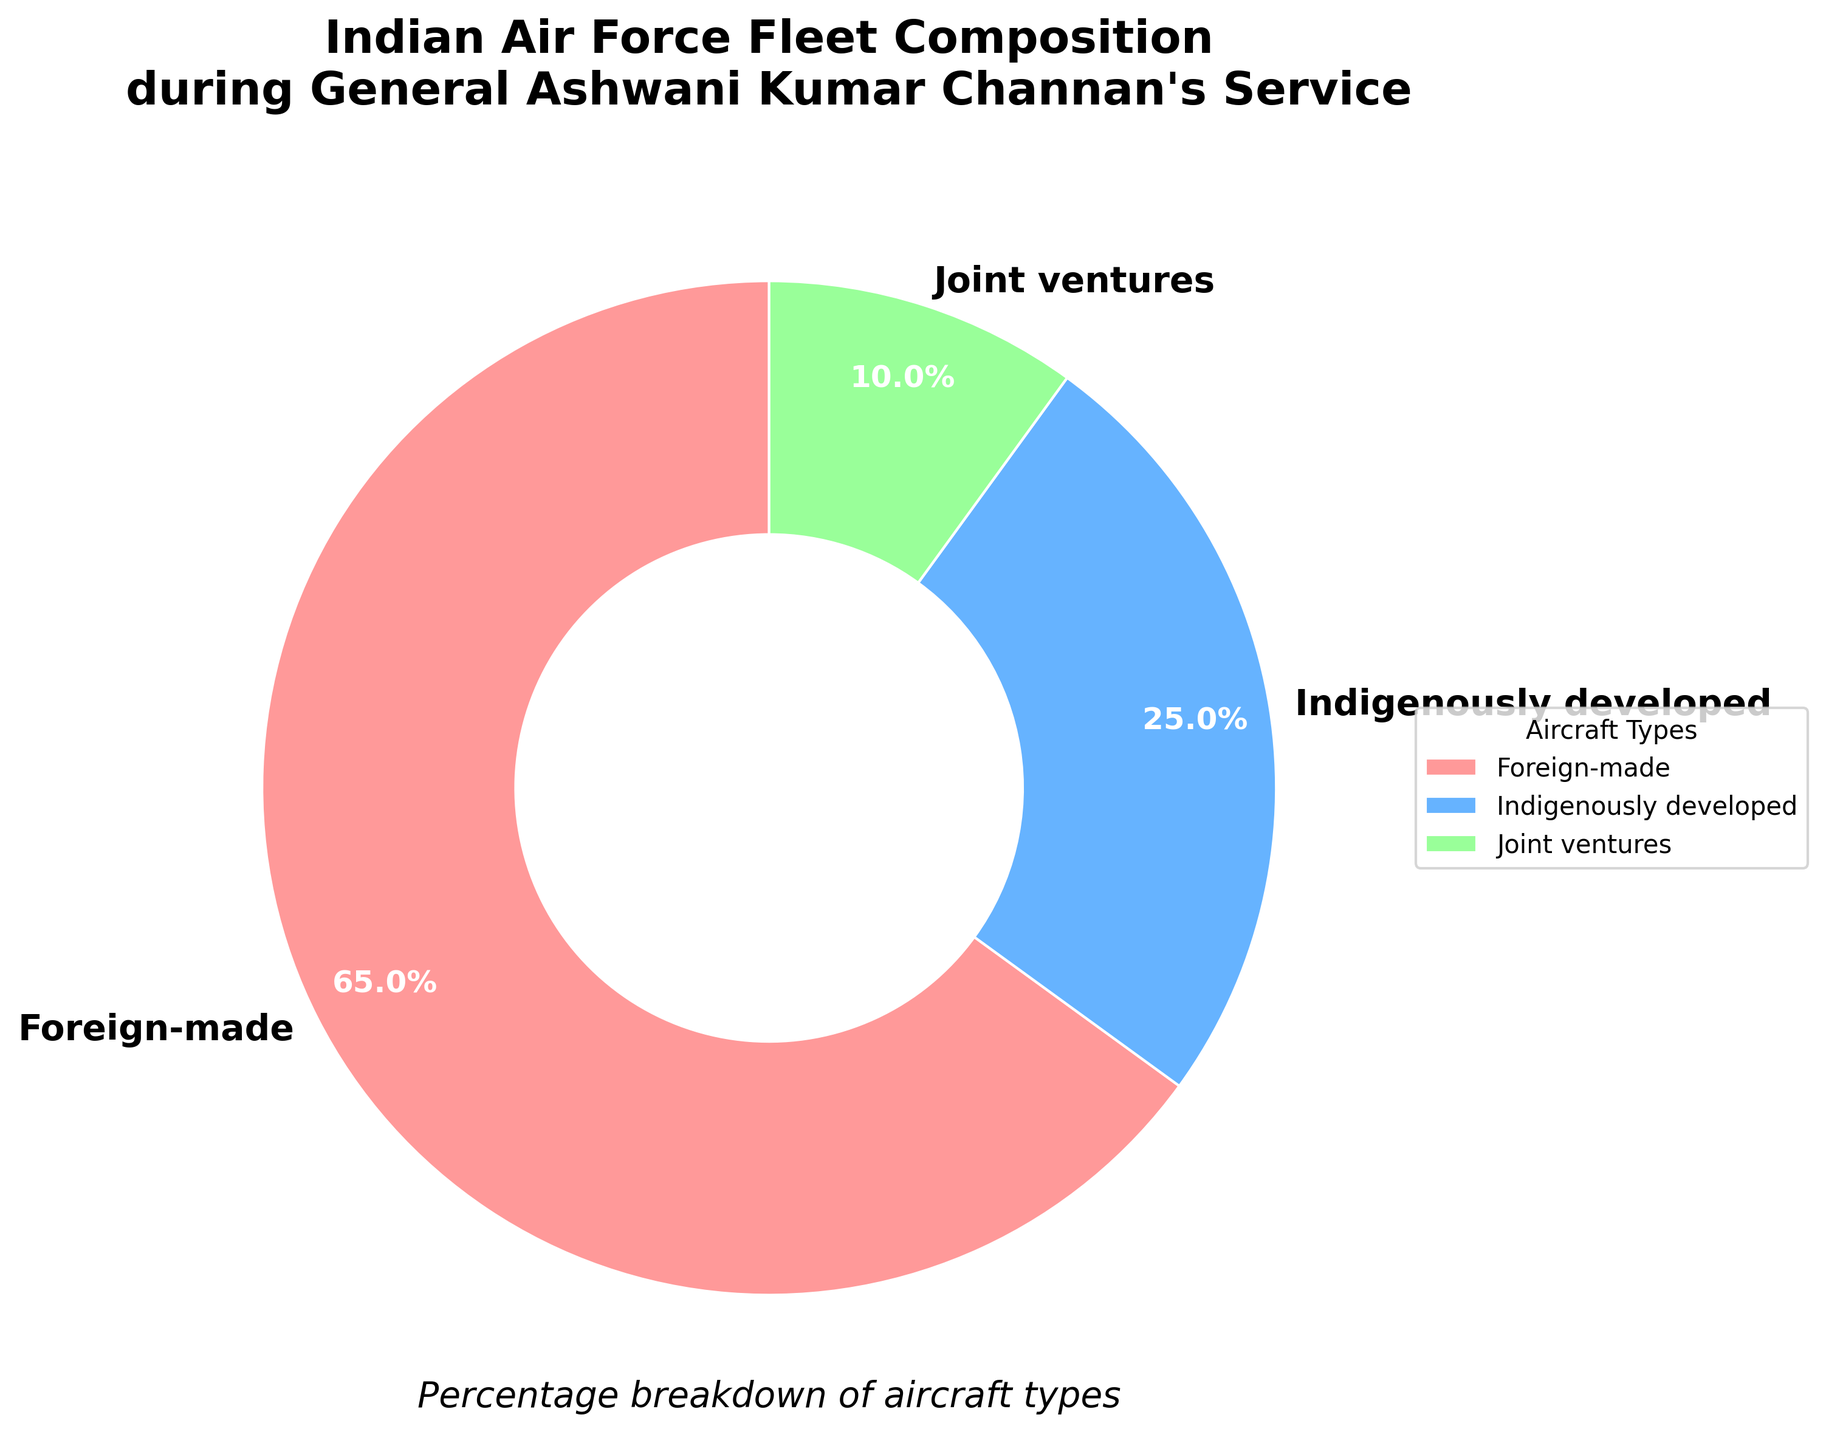What is the percentage of foreign-made aircraft in the Indian Air Force fleet? The pie chart indicates the composition of foreign-made, indigenously developed, and joint venture aircraft. The section labeled "Foreign-made" specifies the percentage of such aircraft.
Answer: 65% Which category has the smallest percentage in the Indian Air Force fleet composition? By comparing the percentages shown in the pie chart, "Joint ventures" has the smallest value at 10%.
Answer: Joint ventures What is the combined percentage of indigenously developed and joint venture aircraft? To find the combined percentage, add the individual percentages of "Indigenously developed" and "Joint ventures": 25% + 10% = 35%.
Answer: 35% How much higher is the percentage of foreign-made aircraft compared to indigenously developed ones? Subtract the percentage of "Indigenously developed" aircraft from that of "Foreign-made" aircraft: 65% - 25% = 40%.
Answer: 40% What visual color represents the indigenously developed aircraft section? The pie chart uses specific colors for each segment. The section labeled "Indigenously developed" appears in blue.
Answer: Blue If the fleet had 200 aircraft, how many would be foreign-made? Given that 65% of the aircraft are foreign-made, calculate 65% of 200: (65/100) * 200 = 130.
Answer: 130 Which category occupies more space: foreign-made or the combined categories of indigenously developed and joint ventures? Compare the percentage of "Foreign-made" (65%) with the combined percentage of "Indigenously developed" and "Joint ventures" (25% + 10% = 35%). "Foreign-made" occupies more space.
Answer: Foreign-made What is the percentage difference between the largest and the smallest categories? Identify the largest percentage (Foreign-made, 65%) and the smallest (Joint ventures, 10%). The difference is 65% - 10% = 55%.
Answer: 55% Which two categories together make up less than 50% of the fleet? Summing the percentages of "Indigenously developed" (25%) and "Joint ventures" (10%) results in 35%, which is less than 50%.
Answer: Indigenously developed and Joint ventures 